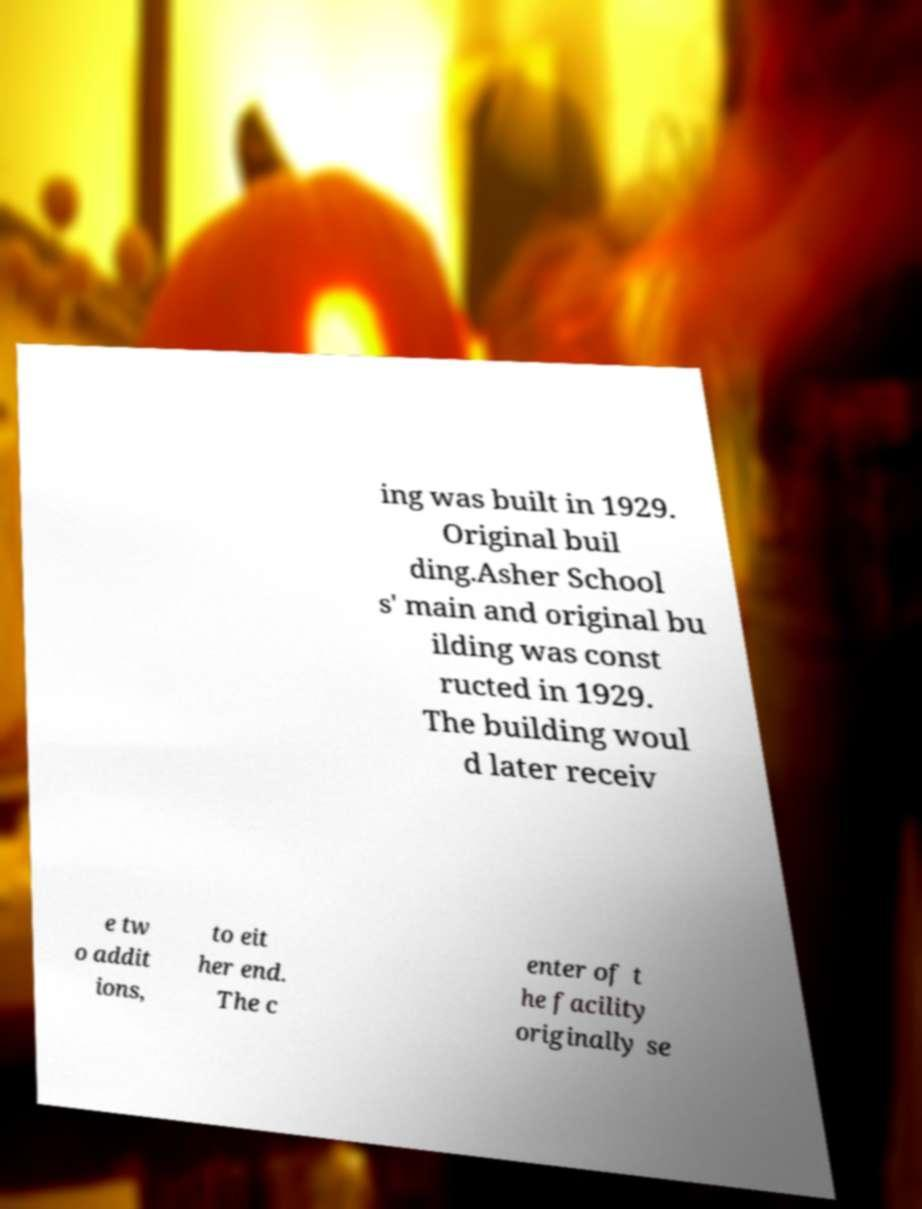Can you accurately transcribe the text from the provided image for me? ing was built in 1929. Original buil ding.Asher School s' main and original bu ilding was const ructed in 1929. The building woul d later receiv e tw o addit ions, to eit her end. The c enter of t he facility originally se 